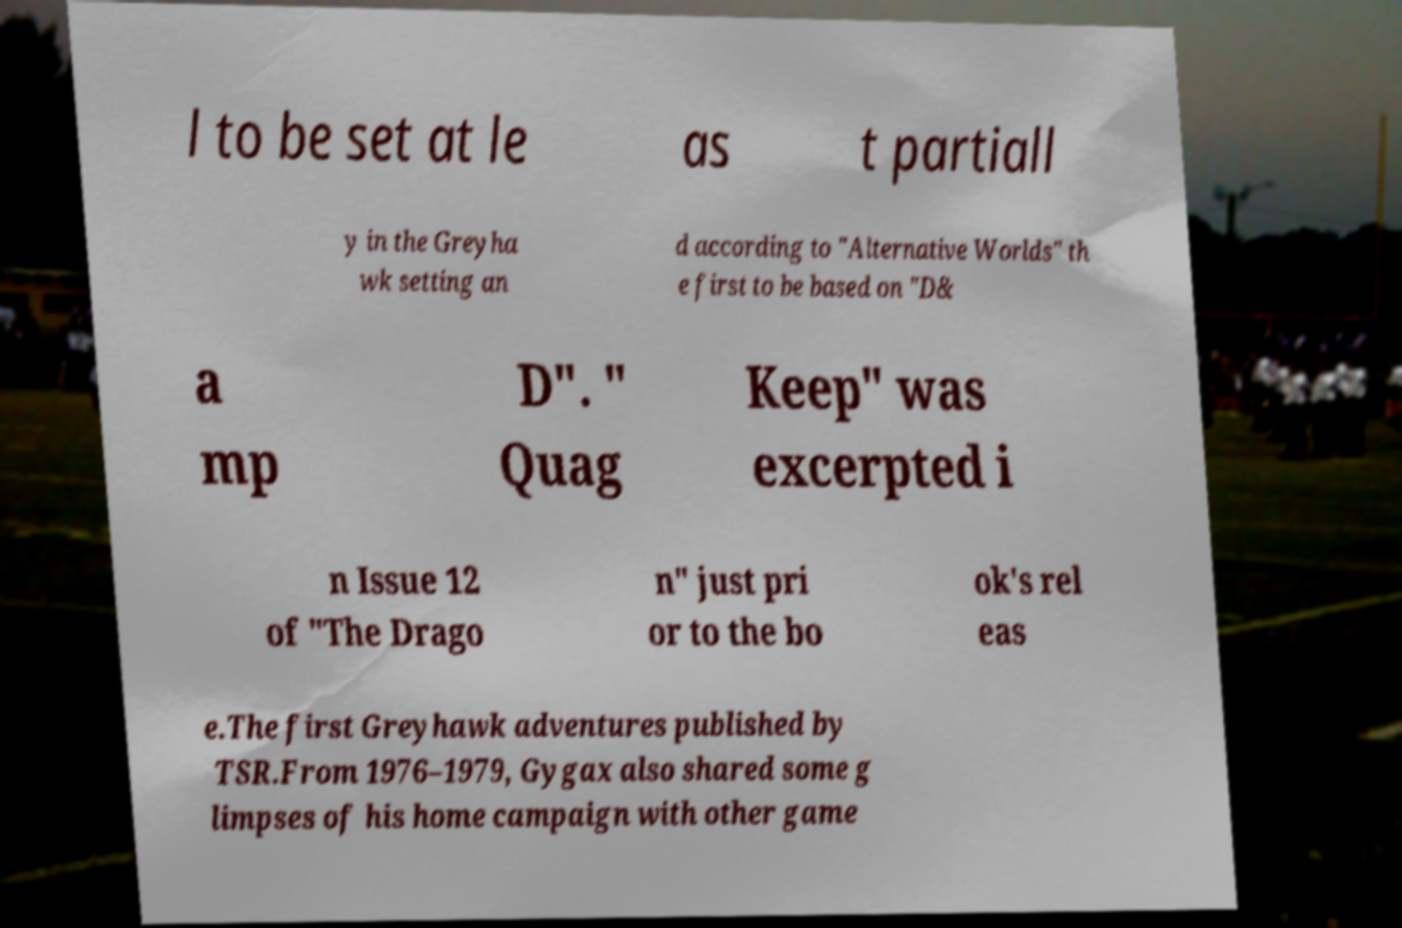Can you accurately transcribe the text from the provided image for me? l to be set at le as t partiall y in the Greyha wk setting an d according to "Alternative Worlds" th e first to be based on "D& a mp D". " Quag Keep" was excerpted i n Issue 12 of "The Drago n" just pri or to the bo ok's rel eas e.The first Greyhawk adventures published by TSR.From 1976–1979, Gygax also shared some g limpses of his home campaign with other game 